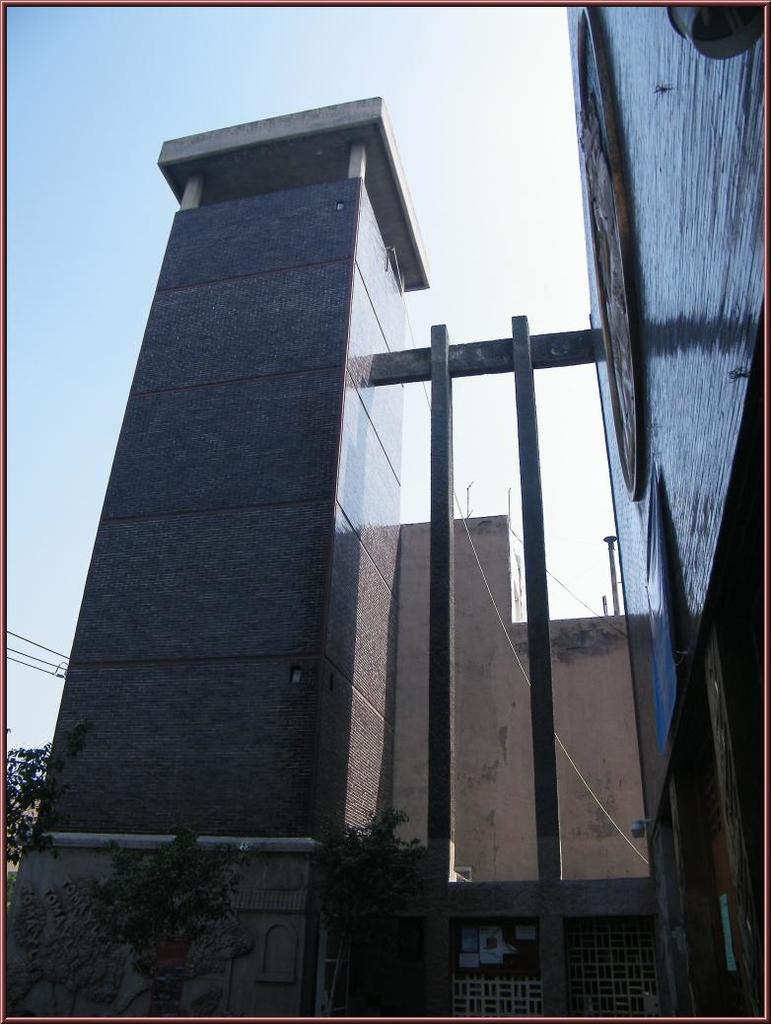Can you describe this image briefly? In the image i can see the building,plants,windows and in the background i can see the sky. 